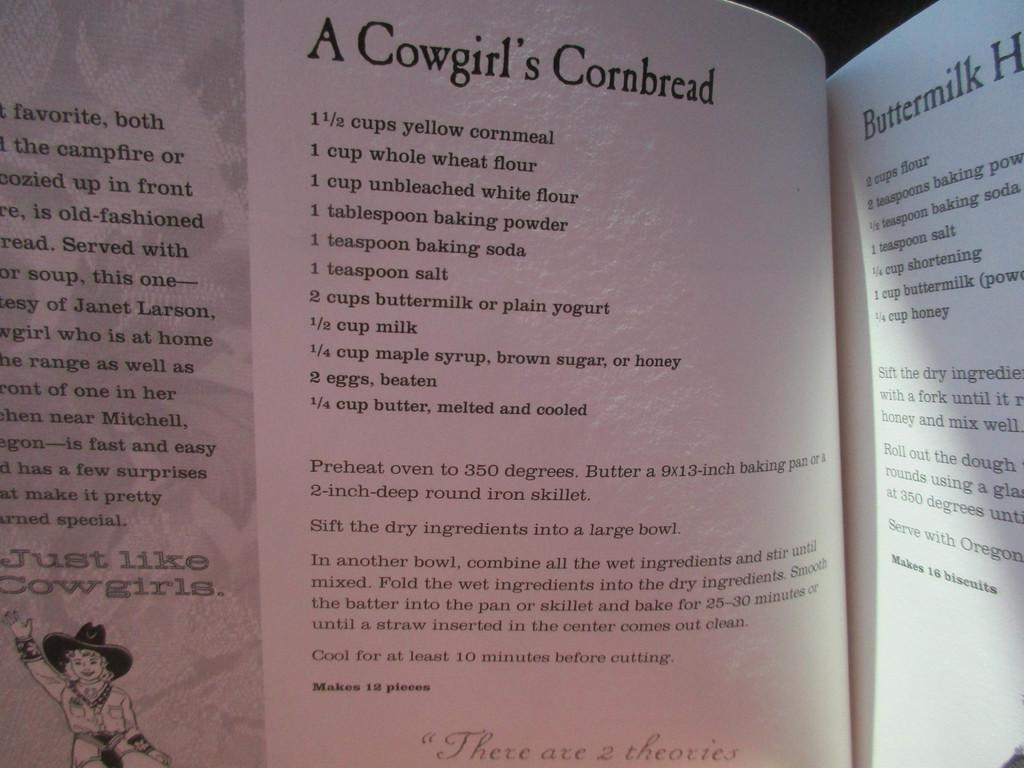What is visible on the pages in the image? There are pages in the image, and there is writing on the pages. Can you describe the content of the writing on the pages? Unfortunately, the specific content of the writing cannot be determined from the image. Is there any imagery depicted on the pages? Yes, there is a depiction of a person on the pages. What type of soup is being served in the image? There is no soup present in the image; it features pages with writing and a depiction of a person. How many clovers can be seen in the image? There are no clovers present in the image. 